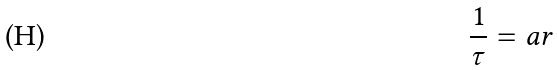<formula> <loc_0><loc_0><loc_500><loc_500>\frac { 1 } { \tau } = a r</formula> 